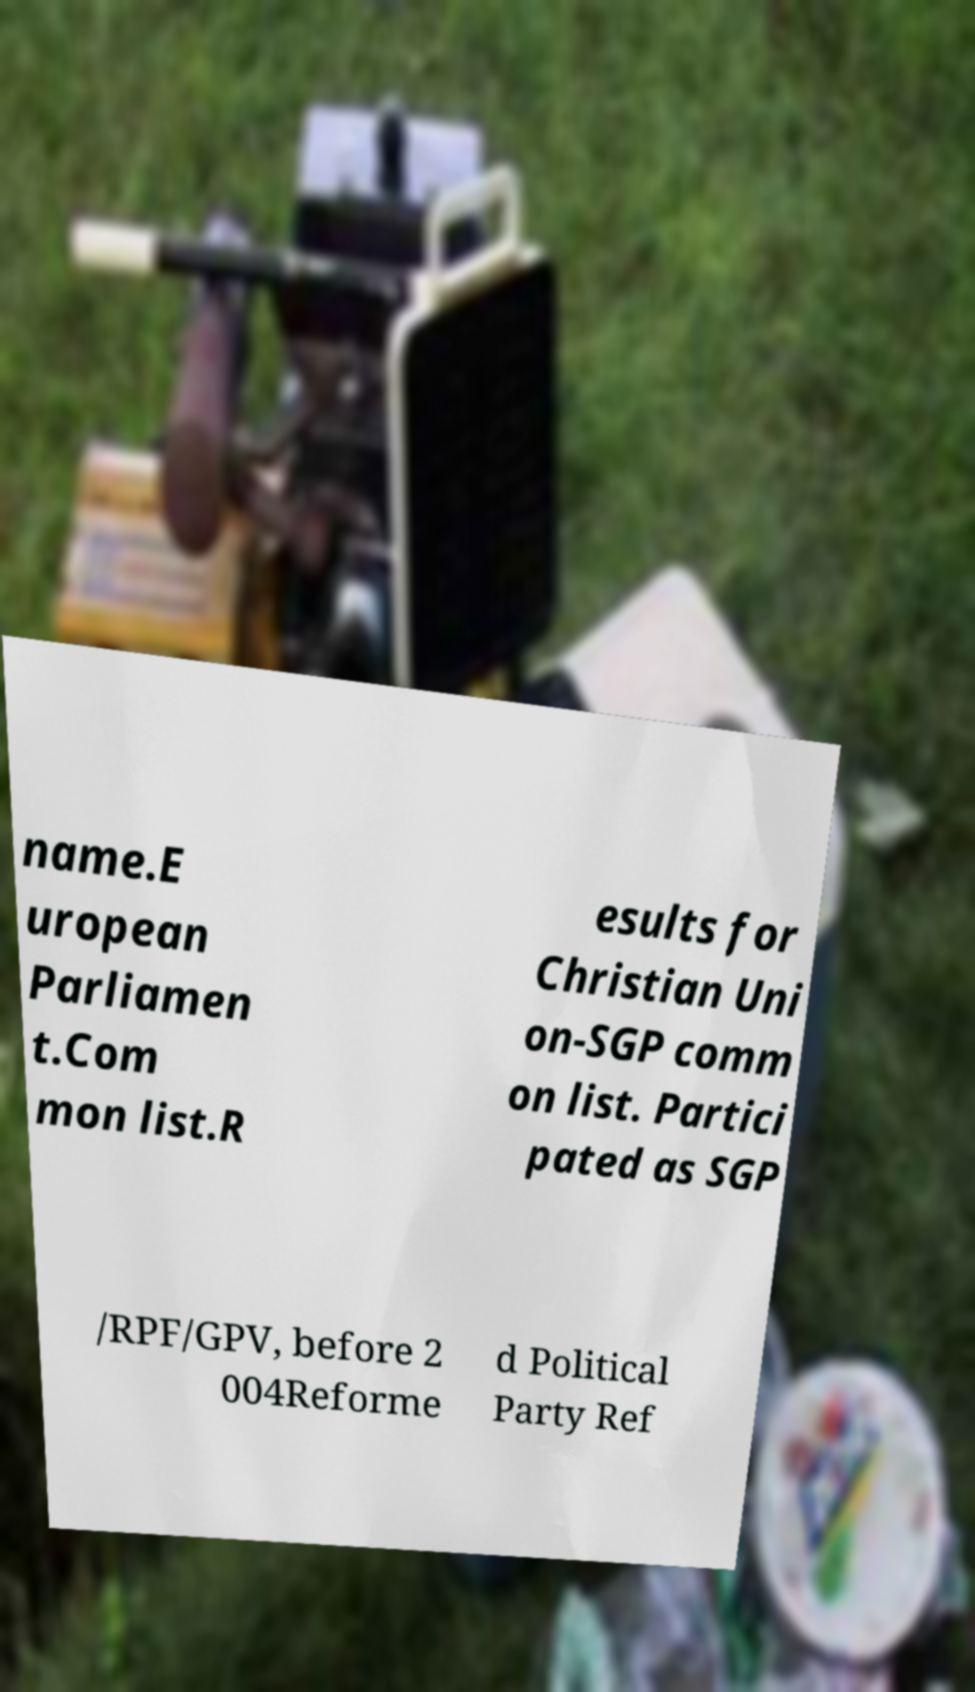Can you read and provide the text displayed in the image?This photo seems to have some interesting text. Can you extract and type it out for me? name.E uropean Parliamen t.Com mon list.R esults for Christian Uni on-SGP comm on list. Partici pated as SGP /RPF/GPV, before 2 004Reforme d Political Party Ref 